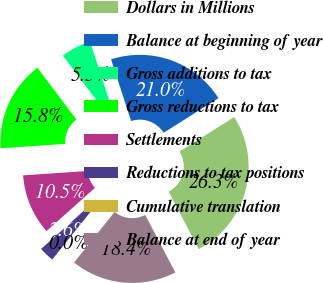<chart> <loc_0><loc_0><loc_500><loc_500><pie_chart><fcel>Dollars in Millions<fcel>Balance at beginning of year<fcel>Gross additions to tax<fcel>Gross reductions to tax<fcel>Settlements<fcel>Reductions to tax positions<fcel>Cumulative translation<fcel>Balance at end of year<nl><fcel>26.3%<fcel>21.04%<fcel>5.27%<fcel>15.79%<fcel>10.53%<fcel>2.64%<fcel>0.01%<fcel>18.41%<nl></chart> 